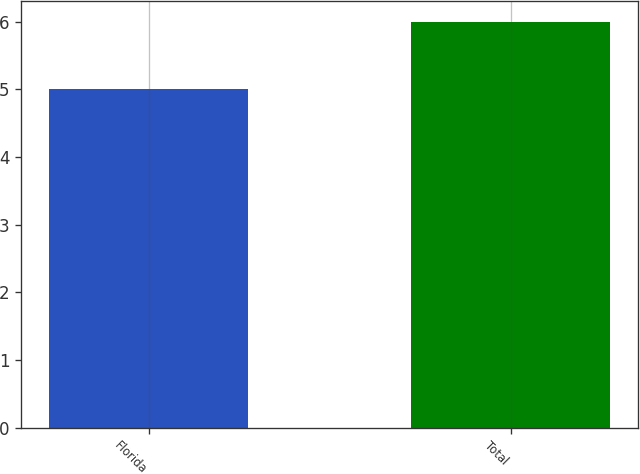<chart> <loc_0><loc_0><loc_500><loc_500><bar_chart><fcel>Florida<fcel>Total<nl><fcel>5<fcel>6<nl></chart> 